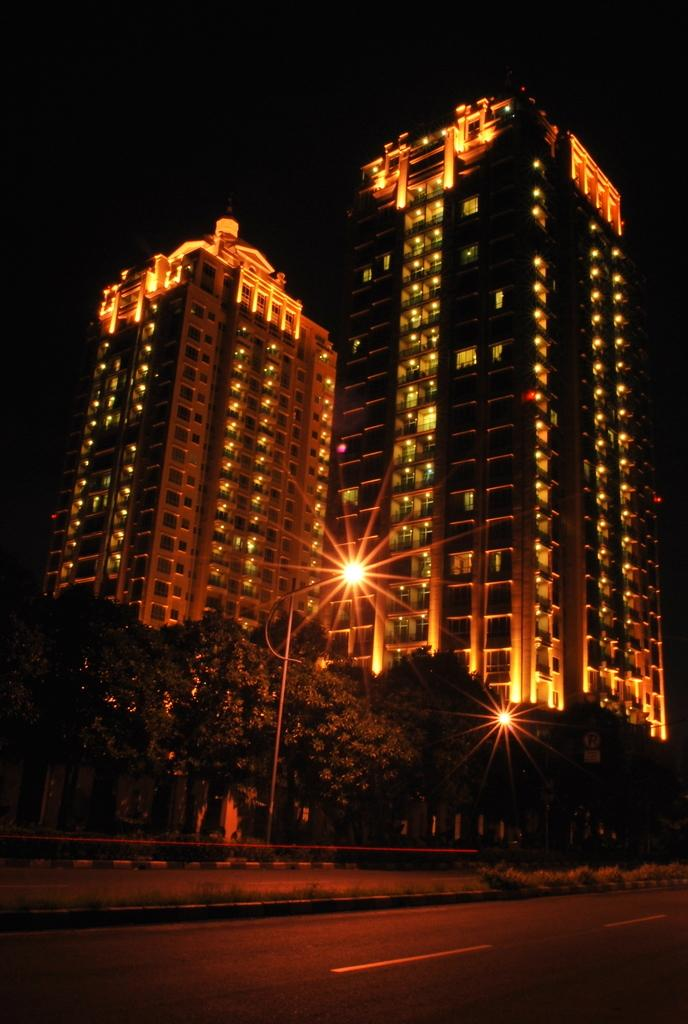What is located in the center of the image? There are buildings, lights, and a pole in the center of the image. What type of vegetation can be seen in the image? There are trees in the image. What is at the bottom of the image? There is a road at the bottom of the image. What is visible at the top of the image? The sky is visible at the top of the image. Can you see a tub in the image? There is no tub present in the image. Is there a cow visible in the image? There is no cow present in the image. 